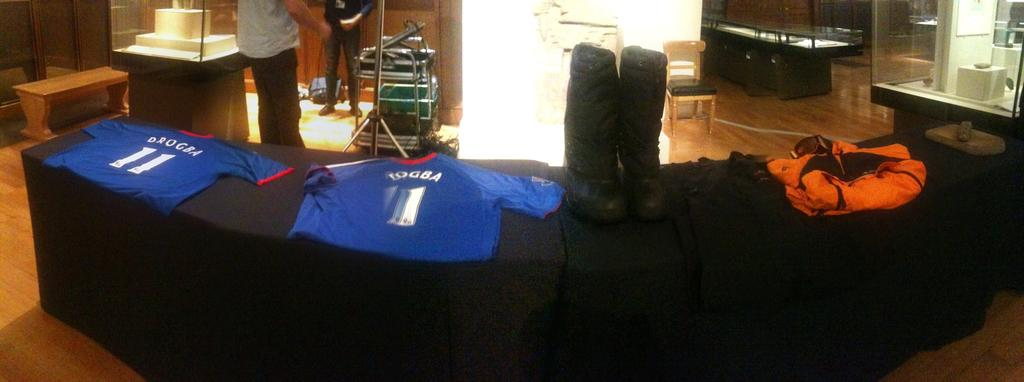<image>
Summarize the visual content of the image. A Drogba, number 11, jersey is laid out on a table covered in black cloth. 